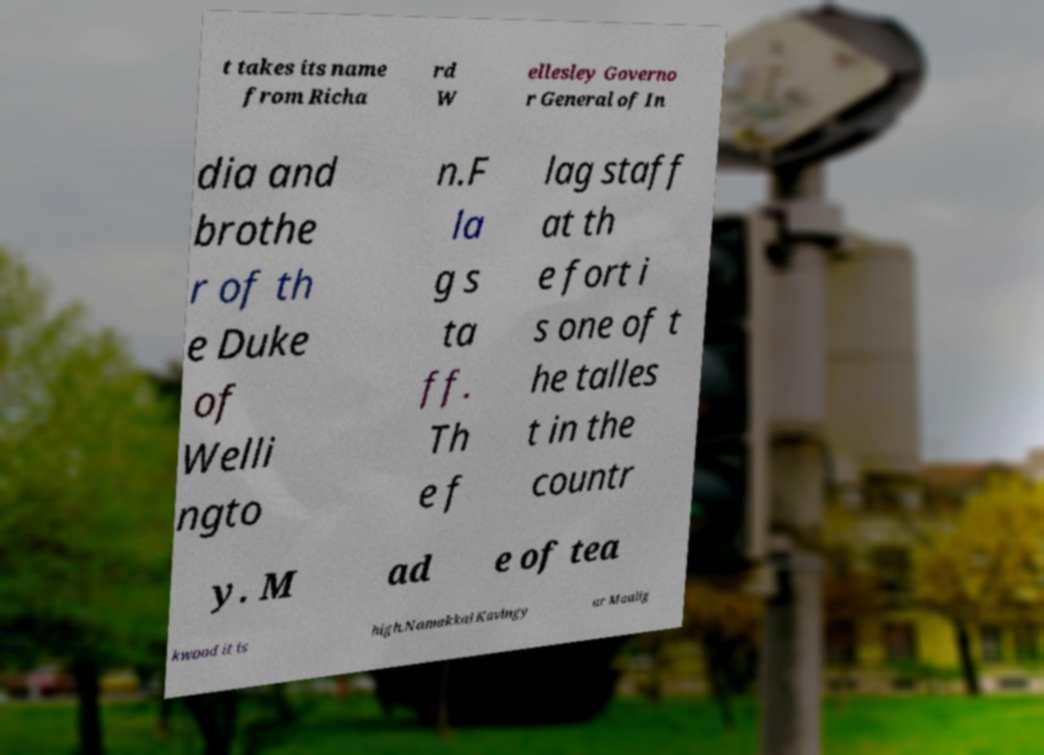Could you assist in decoding the text presented in this image and type it out clearly? t takes its name from Richa rd W ellesley Governo r General of In dia and brothe r of th e Duke of Welli ngto n.F la g s ta ff. Th e f lag staff at th e fort i s one of t he talles t in the countr y. M ad e of tea kwood it is high.Namakkal Kavingy ar Maalig 